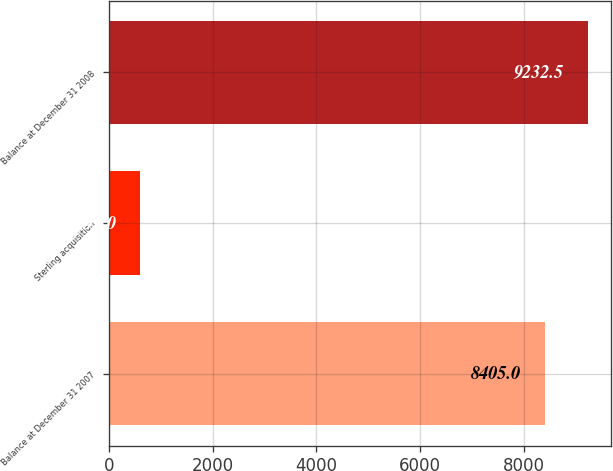<chart> <loc_0><loc_0><loc_500><loc_500><bar_chart><fcel>Balance at December 31 2007<fcel>Sterling acquisition<fcel>Balance at December 31 2008<nl><fcel>8405<fcel>593<fcel>9232.5<nl></chart> 